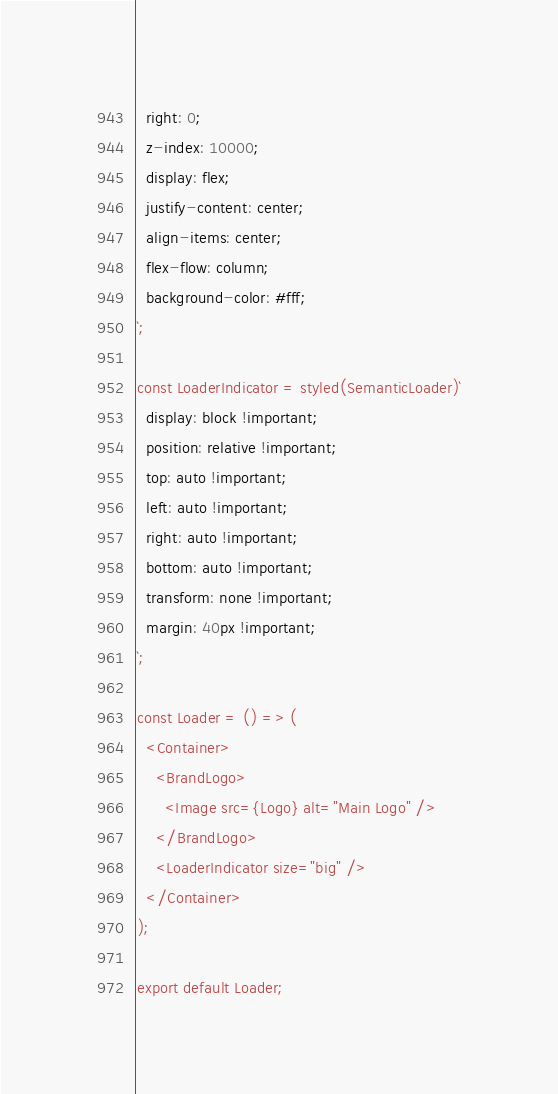Convert code to text. <code><loc_0><loc_0><loc_500><loc_500><_JavaScript_>  right: 0;
  z-index: 10000;
  display: flex;
  justify-content: center;
  align-items: center;
  flex-flow: column;
  background-color: #fff;
`;

const LoaderIndicator = styled(SemanticLoader)`
  display: block !important;
  position: relative !important;
  top: auto !important;
  left: auto !important;
  right: auto !important;
  bottom: auto !important;
  transform: none !important;
  margin: 40px !important;
`;

const Loader = () => (
  <Container>
    <BrandLogo>
      <Image src={Logo} alt="Main Logo" />
    </BrandLogo>
    <LoaderIndicator size="big" />
  </Container>
);

export default Loader;
</code> 